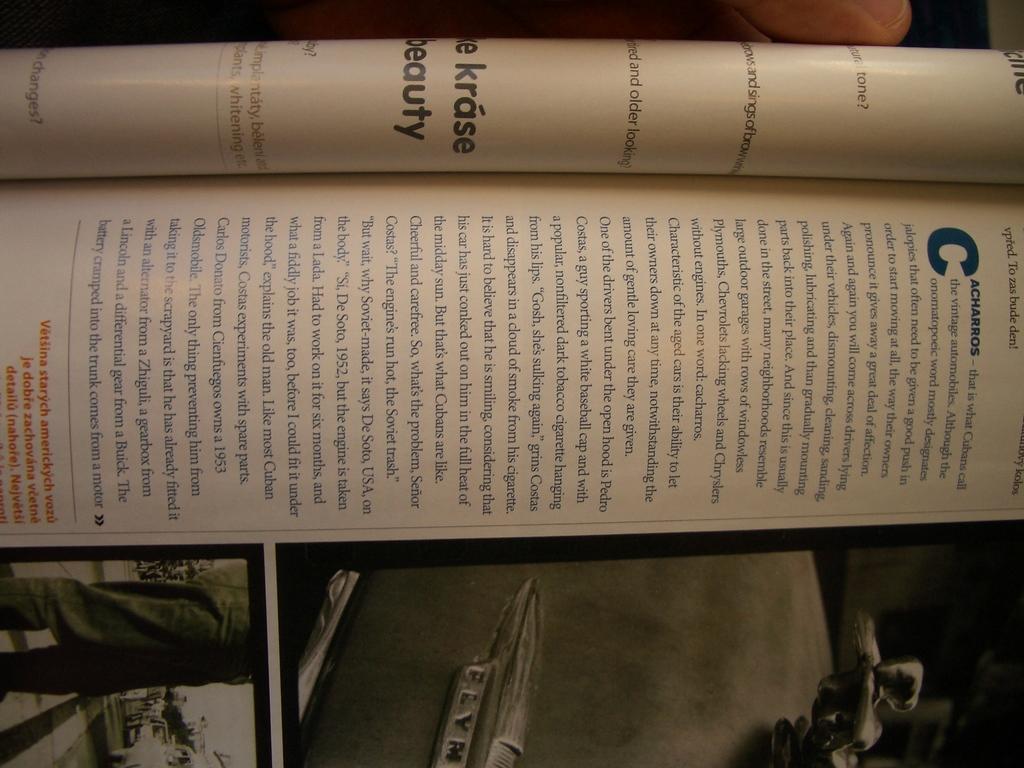What's the first word?
Make the answer very short. Cacharros. 